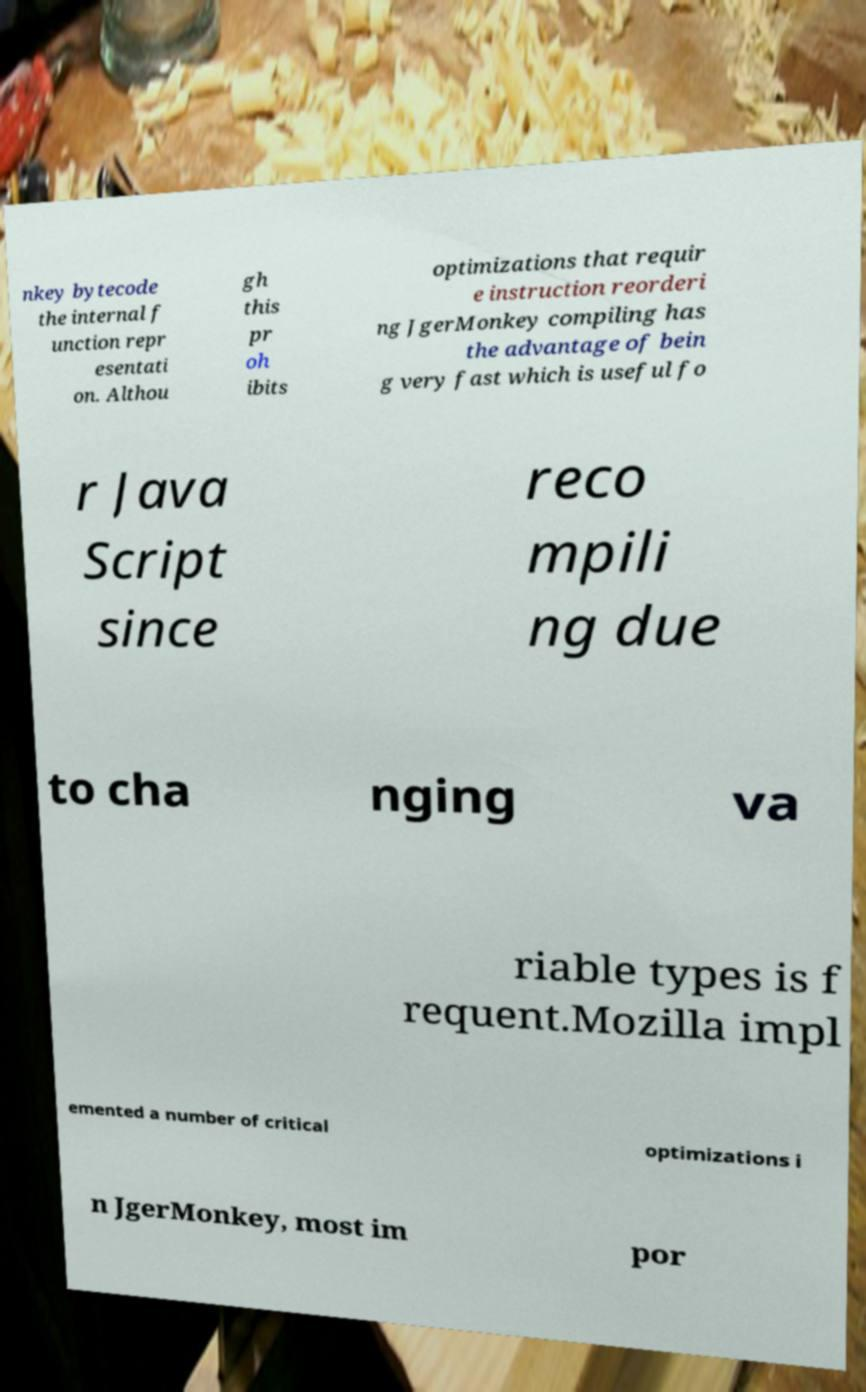Can you accurately transcribe the text from the provided image for me? nkey bytecode the internal f unction repr esentati on. Althou gh this pr oh ibits optimizations that requir e instruction reorderi ng JgerMonkey compiling has the advantage of bein g very fast which is useful fo r Java Script since reco mpili ng due to cha nging va riable types is f requent.Mozilla impl emented a number of critical optimizations i n JgerMonkey, most im por 